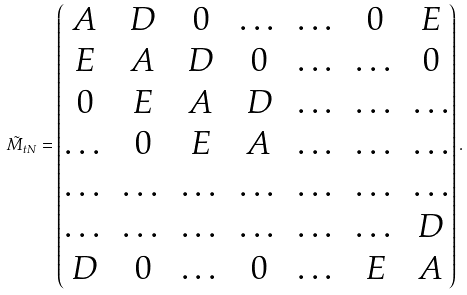Convert formula to latex. <formula><loc_0><loc_0><loc_500><loc_500>\tilde { M } _ { t N } = \begin{pmatrix} A & D & 0 & \dots & \dots & 0 & E \\ E & A & D & 0 & \dots & \dots & 0 \\ 0 & E & A & D & \dots & \dots & \dots \\ \dots & 0 & E & A & \dots & \dots & \dots \\ \dots & \dots & \dots & \dots & \dots & \dots & \dots \\ \dots & \dots & \dots & \dots & \dots & \dots & D \\ D & 0 & \dots & 0 & \dots & E & A \end{pmatrix} .</formula> 